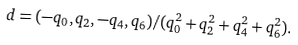<formula> <loc_0><loc_0><loc_500><loc_500>d = ( - q _ { 0 } , q _ { 2 } , - q _ { 4 } , q _ { 6 } ) / ( q _ { 0 } ^ { 2 } + q _ { 2 } ^ { 2 } + q _ { 4 } ^ { 2 } + q _ { 6 } ^ { 2 } ) .</formula> 